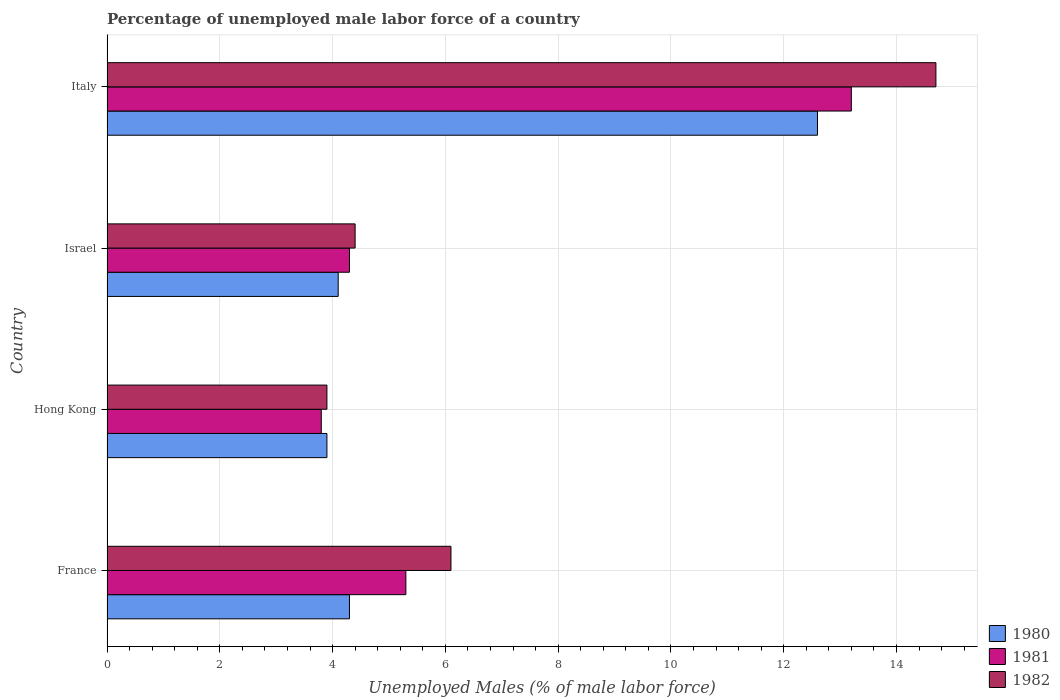How many groups of bars are there?
Offer a terse response. 4. Are the number of bars per tick equal to the number of legend labels?
Provide a short and direct response. Yes. Are the number of bars on each tick of the Y-axis equal?
Make the answer very short. Yes. How many bars are there on the 3rd tick from the top?
Keep it short and to the point. 3. What is the label of the 3rd group of bars from the top?
Your response must be concise. Hong Kong. In how many cases, is the number of bars for a given country not equal to the number of legend labels?
Ensure brevity in your answer.  0. What is the percentage of unemployed male labor force in 1982 in Israel?
Offer a very short reply. 4.4. Across all countries, what is the maximum percentage of unemployed male labor force in 1980?
Your answer should be very brief. 12.6. Across all countries, what is the minimum percentage of unemployed male labor force in 1982?
Your answer should be very brief. 3.9. In which country was the percentage of unemployed male labor force in 1981 minimum?
Provide a short and direct response. Hong Kong. What is the total percentage of unemployed male labor force in 1980 in the graph?
Give a very brief answer. 24.9. What is the difference between the percentage of unemployed male labor force in 1980 in France and that in Hong Kong?
Give a very brief answer. 0.4. What is the difference between the percentage of unemployed male labor force in 1980 in Israel and the percentage of unemployed male labor force in 1981 in France?
Ensure brevity in your answer.  -1.2. What is the average percentage of unemployed male labor force in 1982 per country?
Ensure brevity in your answer.  7.27. What is the difference between the percentage of unemployed male labor force in 1982 and percentage of unemployed male labor force in 1980 in Israel?
Your answer should be very brief. 0.3. What is the ratio of the percentage of unemployed male labor force in 1981 in Hong Kong to that in Israel?
Keep it short and to the point. 0.88. What is the difference between the highest and the second highest percentage of unemployed male labor force in 1982?
Provide a short and direct response. 8.6. What is the difference between the highest and the lowest percentage of unemployed male labor force in 1981?
Keep it short and to the point. 9.4. Is the sum of the percentage of unemployed male labor force in 1980 in France and Italy greater than the maximum percentage of unemployed male labor force in 1981 across all countries?
Your answer should be very brief. Yes. What does the 3rd bar from the top in Israel represents?
Keep it short and to the point. 1980. What does the 2nd bar from the bottom in Israel represents?
Make the answer very short. 1981. Is it the case that in every country, the sum of the percentage of unemployed male labor force in 1980 and percentage of unemployed male labor force in 1981 is greater than the percentage of unemployed male labor force in 1982?
Your response must be concise. Yes. Does the graph contain grids?
Offer a very short reply. Yes. Where does the legend appear in the graph?
Provide a succinct answer. Bottom right. How are the legend labels stacked?
Ensure brevity in your answer.  Vertical. What is the title of the graph?
Provide a succinct answer. Percentage of unemployed male labor force of a country. Does "1996" appear as one of the legend labels in the graph?
Give a very brief answer. No. What is the label or title of the X-axis?
Provide a short and direct response. Unemployed Males (% of male labor force). What is the Unemployed Males (% of male labor force) in 1980 in France?
Offer a terse response. 4.3. What is the Unemployed Males (% of male labor force) in 1981 in France?
Ensure brevity in your answer.  5.3. What is the Unemployed Males (% of male labor force) of 1982 in France?
Your answer should be very brief. 6.1. What is the Unemployed Males (% of male labor force) of 1980 in Hong Kong?
Your answer should be very brief. 3.9. What is the Unemployed Males (% of male labor force) in 1981 in Hong Kong?
Your answer should be very brief. 3.8. What is the Unemployed Males (% of male labor force) of 1982 in Hong Kong?
Your answer should be compact. 3.9. What is the Unemployed Males (% of male labor force) of 1980 in Israel?
Make the answer very short. 4.1. What is the Unemployed Males (% of male labor force) in 1981 in Israel?
Keep it short and to the point. 4.3. What is the Unemployed Males (% of male labor force) of 1982 in Israel?
Ensure brevity in your answer.  4.4. What is the Unemployed Males (% of male labor force) of 1980 in Italy?
Offer a very short reply. 12.6. What is the Unemployed Males (% of male labor force) of 1981 in Italy?
Provide a short and direct response. 13.2. What is the Unemployed Males (% of male labor force) in 1982 in Italy?
Give a very brief answer. 14.7. Across all countries, what is the maximum Unemployed Males (% of male labor force) of 1980?
Keep it short and to the point. 12.6. Across all countries, what is the maximum Unemployed Males (% of male labor force) in 1981?
Provide a succinct answer. 13.2. Across all countries, what is the maximum Unemployed Males (% of male labor force) in 1982?
Your answer should be compact. 14.7. Across all countries, what is the minimum Unemployed Males (% of male labor force) of 1980?
Offer a terse response. 3.9. Across all countries, what is the minimum Unemployed Males (% of male labor force) of 1981?
Your response must be concise. 3.8. Across all countries, what is the minimum Unemployed Males (% of male labor force) of 1982?
Ensure brevity in your answer.  3.9. What is the total Unemployed Males (% of male labor force) of 1980 in the graph?
Your response must be concise. 24.9. What is the total Unemployed Males (% of male labor force) of 1981 in the graph?
Your response must be concise. 26.6. What is the total Unemployed Males (% of male labor force) in 1982 in the graph?
Offer a very short reply. 29.1. What is the difference between the Unemployed Males (% of male labor force) in 1981 in France and that in Hong Kong?
Your response must be concise. 1.5. What is the difference between the Unemployed Males (% of male labor force) in 1981 in France and that in Israel?
Offer a terse response. 1. What is the difference between the Unemployed Males (% of male labor force) in 1980 in France and that in Italy?
Ensure brevity in your answer.  -8.3. What is the difference between the Unemployed Males (% of male labor force) of 1981 in France and that in Italy?
Keep it short and to the point. -7.9. What is the difference between the Unemployed Males (% of male labor force) in 1982 in France and that in Italy?
Your response must be concise. -8.6. What is the difference between the Unemployed Males (% of male labor force) of 1981 in Hong Kong and that in Israel?
Provide a short and direct response. -0.5. What is the difference between the Unemployed Males (% of male labor force) of 1980 in France and the Unemployed Males (% of male labor force) of 1982 in Hong Kong?
Ensure brevity in your answer.  0.4. What is the difference between the Unemployed Males (% of male labor force) in 1981 in France and the Unemployed Males (% of male labor force) in 1982 in Hong Kong?
Keep it short and to the point. 1.4. What is the difference between the Unemployed Males (% of male labor force) of 1980 in France and the Unemployed Males (% of male labor force) of 1981 in Israel?
Offer a very short reply. 0. What is the difference between the Unemployed Males (% of male labor force) in 1981 in France and the Unemployed Males (% of male labor force) in 1982 in Italy?
Make the answer very short. -9.4. What is the difference between the Unemployed Males (% of male labor force) of 1980 in Hong Kong and the Unemployed Males (% of male labor force) of 1982 in Israel?
Offer a very short reply. -0.5. What is the difference between the Unemployed Males (% of male labor force) of 1981 in Hong Kong and the Unemployed Males (% of male labor force) of 1982 in Israel?
Your response must be concise. -0.6. What is the difference between the Unemployed Males (% of male labor force) of 1980 in Hong Kong and the Unemployed Males (% of male labor force) of 1981 in Italy?
Provide a short and direct response. -9.3. What is the difference between the Unemployed Males (% of male labor force) in 1980 in Hong Kong and the Unemployed Males (% of male labor force) in 1982 in Italy?
Your answer should be very brief. -10.8. What is the difference between the Unemployed Males (% of male labor force) in 1981 in Hong Kong and the Unemployed Males (% of male labor force) in 1982 in Italy?
Give a very brief answer. -10.9. What is the average Unemployed Males (% of male labor force) in 1980 per country?
Provide a succinct answer. 6.22. What is the average Unemployed Males (% of male labor force) of 1981 per country?
Your answer should be very brief. 6.65. What is the average Unemployed Males (% of male labor force) in 1982 per country?
Keep it short and to the point. 7.28. What is the difference between the Unemployed Males (% of male labor force) of 1980 and Unemployed Males (% of male labor force) of 1981 in France?
Your response must be concise. -1. What is the difference between the Unemployed Males (% of male labor force) in 1981 and Unemployed Males (% of male labor force) in 1982 in France?
Provide a succinct answer. -0.8. What is the difference between the Unemployed Males (% of male labor force) of 1980 and Unemployed Males (% of male labor force) of 1981 in Hong Kong?
Your response must be concise. 0.1. What is the difference between the Unemployed Males (% of male labor force) of 1980 and Unemployed Males (% of male labor force) of 1981 in Israel?
Provide a short and direct response. -0.2. What is the difference between the Unemployed Males (% of male labor force) of 1980 and Unemployed Males (% of male labor force) of 1982 in Israel?
Keep it short and to the point. -0.3. What is the difference between the Unemployed Males (% of male labor force) in 1981 and Unemployed Males (% of male labor force) in 1982 in Israel?
Give a very brief answer. -0.1. What is the ratio of the Unemployed Males (% of male labor force) of 1980 in France to that in Hong Kong?
Offer a very short reply. 1.1. What is the ratio of the Unemployed Males (% of male labor force) of 1981 in France to that in Hong Kong?
Offer a very short reply. 1.39. What is the ratio of the Unemployed Males (% of male labor force) in 1982 in France to that in Hong Kong?
Provide a succinct answer. 1.56. What is the ratio of the Unemployed Males (% of male labor force) of 1980 in France to that in Israel?
Keep it short and to the point. 1.05. What is the ratio of the Unemployed Males (% of male labor force) of 1981 in France to that in Israel?
Offer a terse response. 1.23. What is the ratio of the Unemployed Males (% of male labor force) in 1982 in France to that in Israel?
Offer a terse response. 1.39. What is the ratio of the Unemployed Males (% of male labor force) of 1980 in France to that in Italy?
Offer a terse response. 0.34. What is the ratio of the Unemployed Males (% of male labor force) in 1981 in France to that in Italy?
Provide a short and direct response. 0.4. What is the ratio of the Unemployed Males (% of male labor force) in 1982 in France to that in Italy?
Offer a very short reply. 0.41. What is the ratio of the Unemployed Males (% of male labor force) in 1980 in Hong Kong to that in Israel?
Ensure brevity in your answer.  0.95. What is the ratio of the Unemployed Males (% of male labor force) of 1981 in Hong Kong to that in Israel?
Offer a terse response. 0.88. What is the ratio of the Unemployed Males (% of male labor force) of 1982 in Hong Kong to that in Israel?
Offer a terse response. 0.89. What is the ratio of the Unemployed Males (% of male labor force) of 1980 in Hong Kong to that in Italy?
Your response must be concise. 0.31. What is the ratio of the Unemployed Males (% of male labor force) in 1981 in Hong Kong to that in Italy?
Make the answer very short. 0.29. What is the ratio of the Unemployed Males (% of male labor force) in 1982 in Hong Kong to that in Italy?
Ensure brevity in your answer.  0.27. What is the ratio of the Unemployed Males (% of male labor force) of 1980 in Israel to that in Italy?
Give a very brief answer. 0.33. What is the ratio of the Unemployed Males (% of male labor force) of 1981 in Israel to that in Italy?
Your answer should be very brief. 0.33. What is the ratio of the Unemployed Males (% of male labor force) of 1982 in Israel to that in Italy?
Offer a very short reply. 0.3. What is the difference between the highest and the second highest Unemployed Males (% of male labor force) in 1980?
Provide a short and direct response. 8.3. What is the difference between the highest and the second highest Unemployed Males (% of male labor force) in 1982?
Offer a very short reply. 8.6. What is the difference between the highest and the lowest Unemployed Males (% of male labor force) in 1982?
Provide a short and direct response. 10.8. 